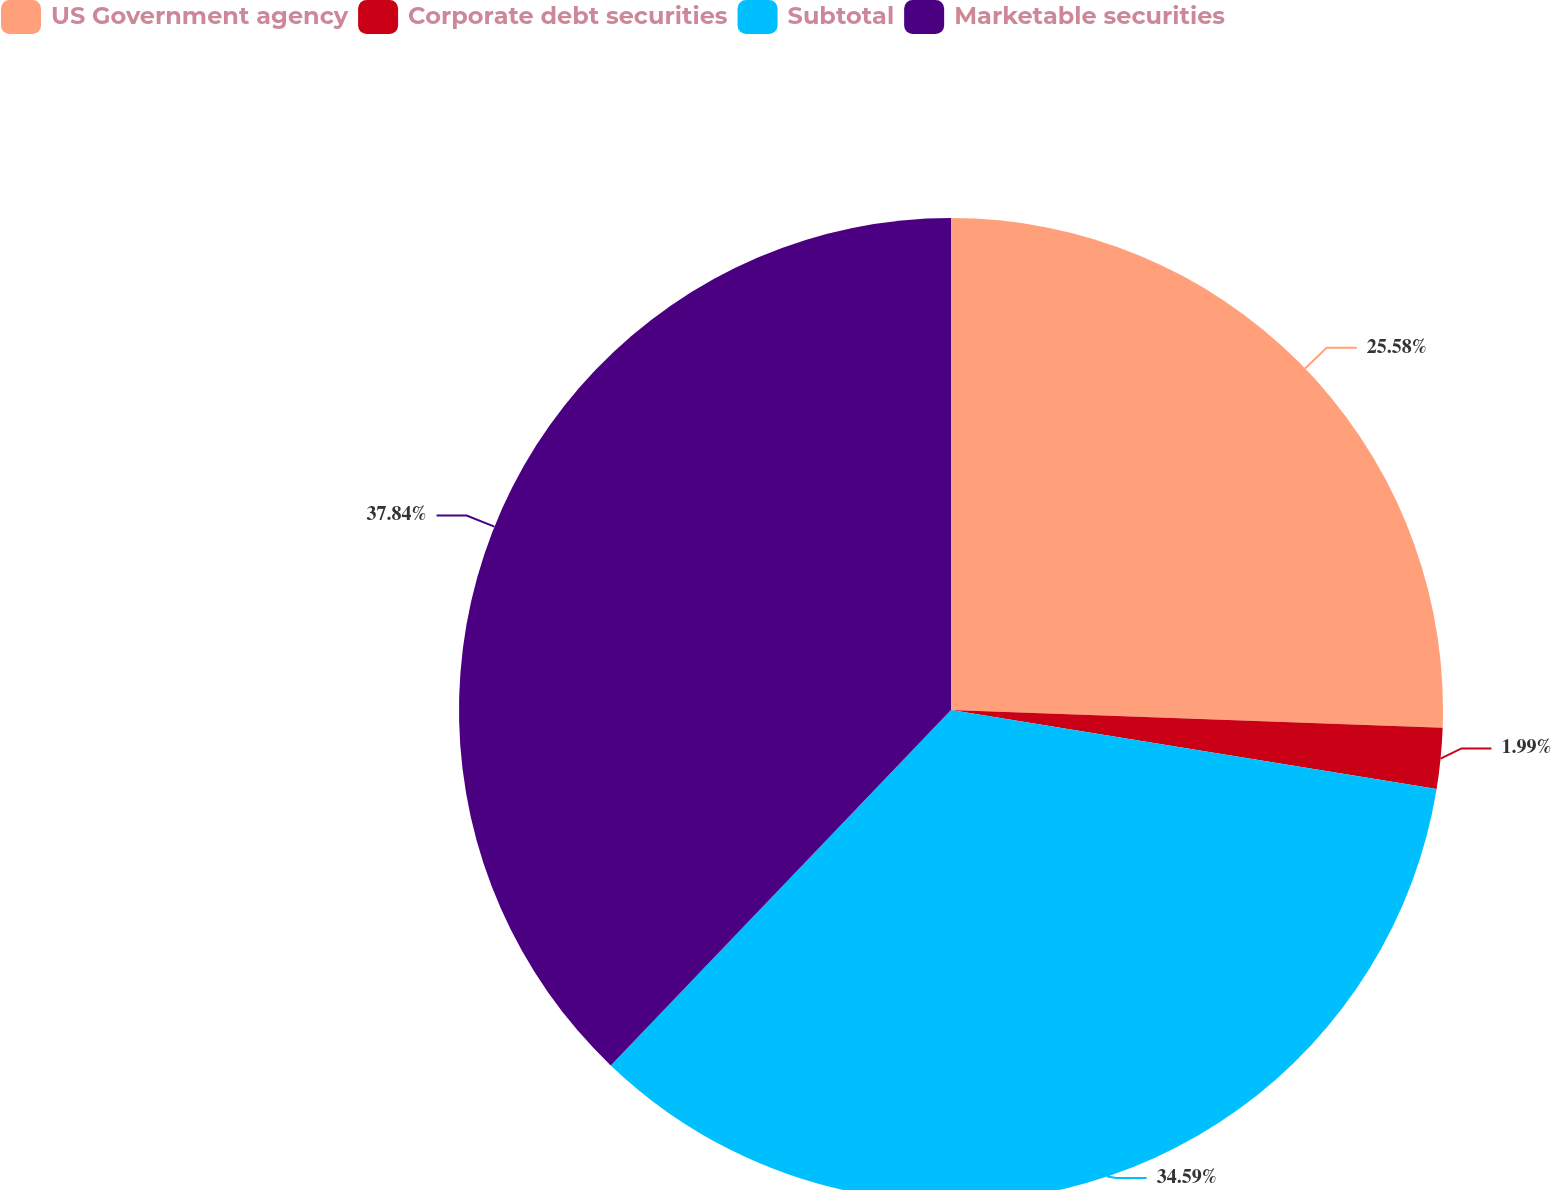Convert chart. <chart><loc_0><loc_0><loc_500><loc_500><pie_chart><fcel>US Government agency<fcel>Corporate debt securities<fcel>Subtotal<fcel>Marketable securities<nl><fcel>25.58%<fcel>1.99%<fcel>34.59%<fcel>37.85%<nl></chart> 